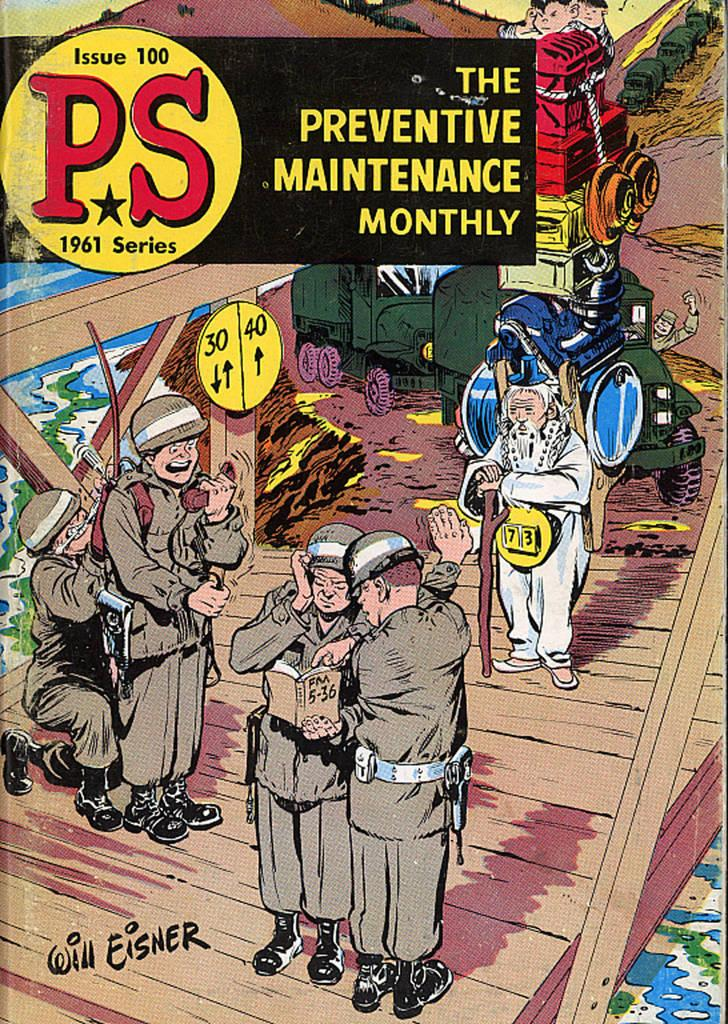<image>
Relay a brief, clear account of the picture shown. The cover of PS issue 100 has people in military uniforms and an older man with a walking stick. 